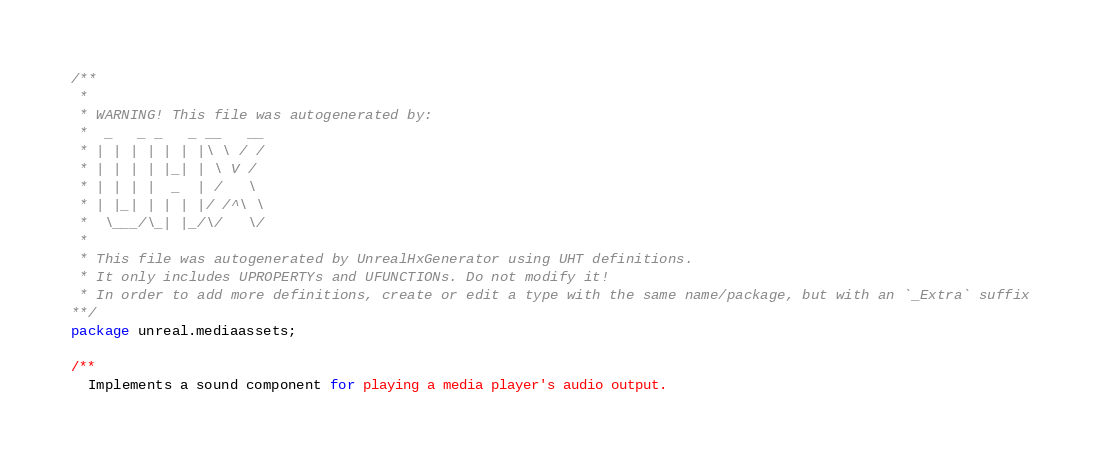<code> <loc_0><loc_0><loc_500><loc_500><_Haxe_>/**
 * 
 * WARNING! This file was autogenerated by: 
 *  _   _ _   _ __   __ 
 * | | | | | | |\ \ / / 
 * | | | | |_| | \ V /  
 * | | | |  _  | /   \  
 * | |_| | | | |/ /^\ \ 
 *  \___/\_| |_/\/   \/ 
 * 
 * This file was autogenerated by UnrealHxGenerator using UHT definitions.
 * It only includes UPROPERTYs and UFUNCTIONs. Do not modify it!
 * In order to add more definitions, create or edit a type with the same name/package, but with an `_Extra` suffix
**/
package unreal.mediaassets;

/**
  Implements a sound component for playing a media player's audio output.</code> 